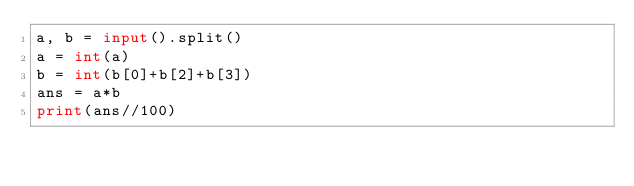<code> <loc_0><loc_0><loc_500><loc_500><_Python_>a, b = input().split()
a = int(a)
b = int(b[0]+b[2]+b[3])
ans = a*b
print(ans//100)</code> 